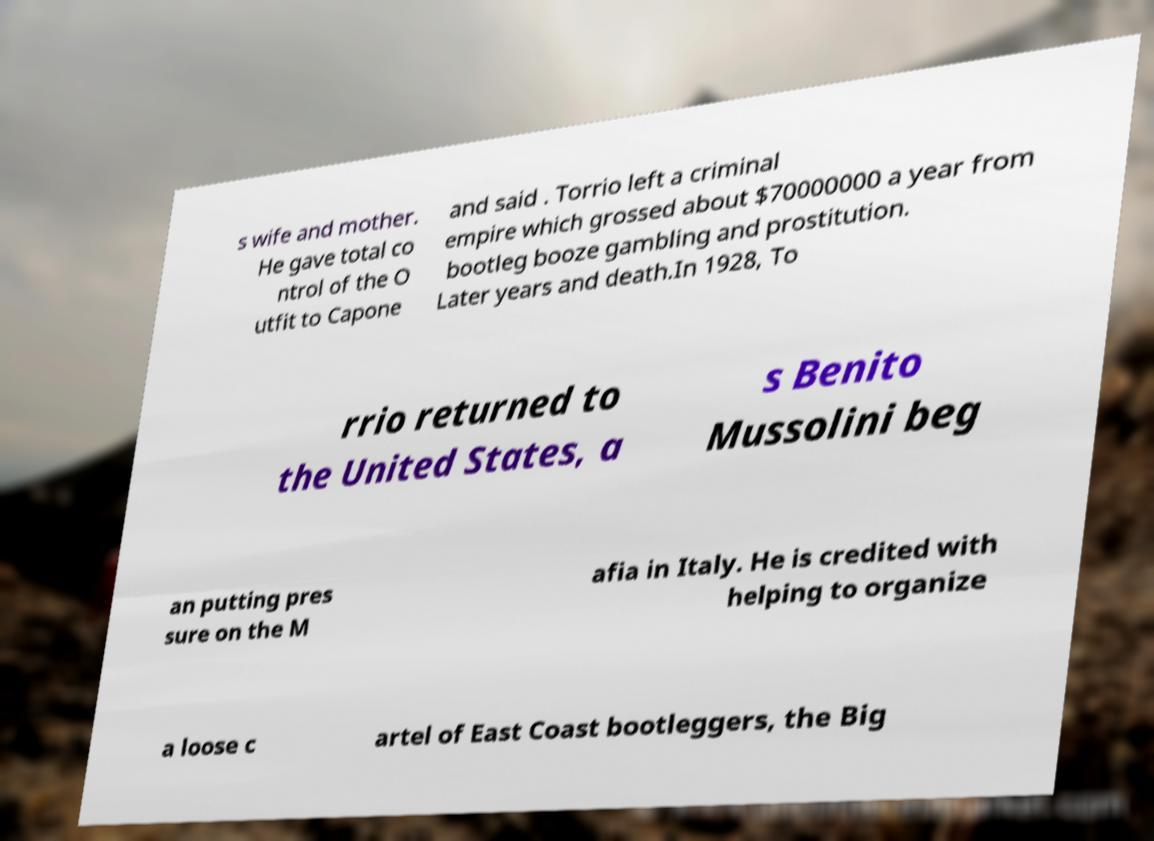Could you extract and type out the text from this image? s wife and mother. He gave total co ntrol of the O utfit to Capone and said . Torrio left a criminal empire which grossed about $70000000 a year from bootleg booze gambling and prostitution. Later years and death.In 1928, To rrio returned to the United States, a s Benito Mussolini beg an putting pres sure on the M afia in Italy. He is credited with helping to organize a loose c artel of East Coast bootleggers, the Big 